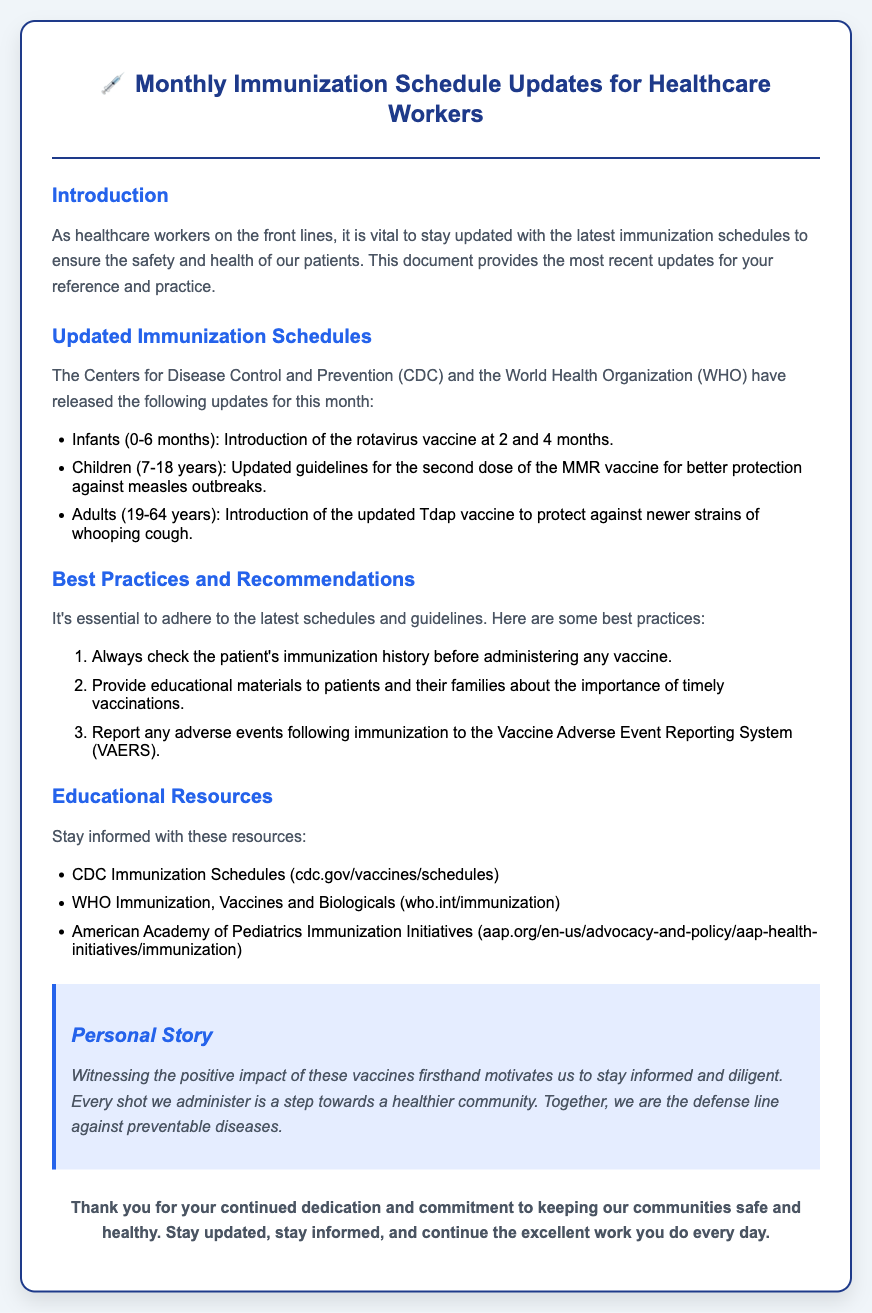What are the updated immunization guidelines for infants? The guidelines specify the introduction of the rotavirus vaccine at 2 and 4 months for infants.
Answer: Rotavirus vaccine at 2 and 4 months What age group has updated MMR vaccine guidelines? The document states that updated guidelines for the second dose of the MMR vaccine are provided for children aged 7-18 years.
Answer: Children (7-18 years) What is a best practice before administering a vaccine? One of the best practices mentioned is to always check the patient's immunization history before administering any vaccine.
Answer: Check immunization history What personal motivation is shared in the document? The document shares that witnessing the positive impact of vaccines motivates the team to stay informed and diligent.
Answer: Positive impact of vaccines How many updates are listed in the immunization schedules section? There are three updated immunization schedules mentioned in the document.
Answer: Three updates What resource is provided for CDC immunization schedules? The document mentions the CDC Immunization Schedules as a resource accessible at cdc.gov/vaccines/schedules.
Answer: cdc.gov/vaccines/schedules What should be reported after an adverse event following immunization? The document states that adverse events following immunization should be reported to the Vaccine Adverse Event Reporting System (VAERS).
Answer: Vaccine Adverse Event Reporting System (VAERS) What is the main focus of the document? The main focus is to provide healthcare workers with updated immunization schedules and best practices.
Answer: Updated immunization schedules and best practices 